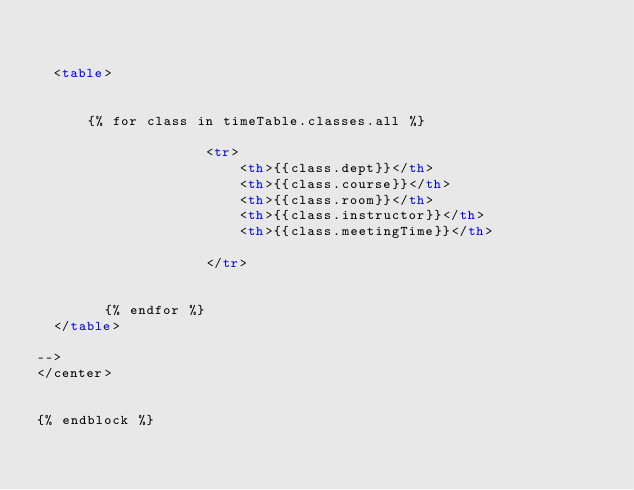Convert code to text. <code><loc_0><loc_0><loc_500><loc_500><_HTML_>  
  
  <table>

    
      {% for class in timeTable.classes.all %}              
       
                    <tr>
                        <th>{{class.dept}}</th>
                        <th>{{class.course}}</th>
                        <th>{{class.room}}</th>
                        <th>{{class.instructor}}</th>
                        <th>{{class.meetingTime}}</th>
                    
                    </tr>   
                                    
              
        {% endfor %}
  </table>
  
-->
</center>


{% endblock %}</code> 